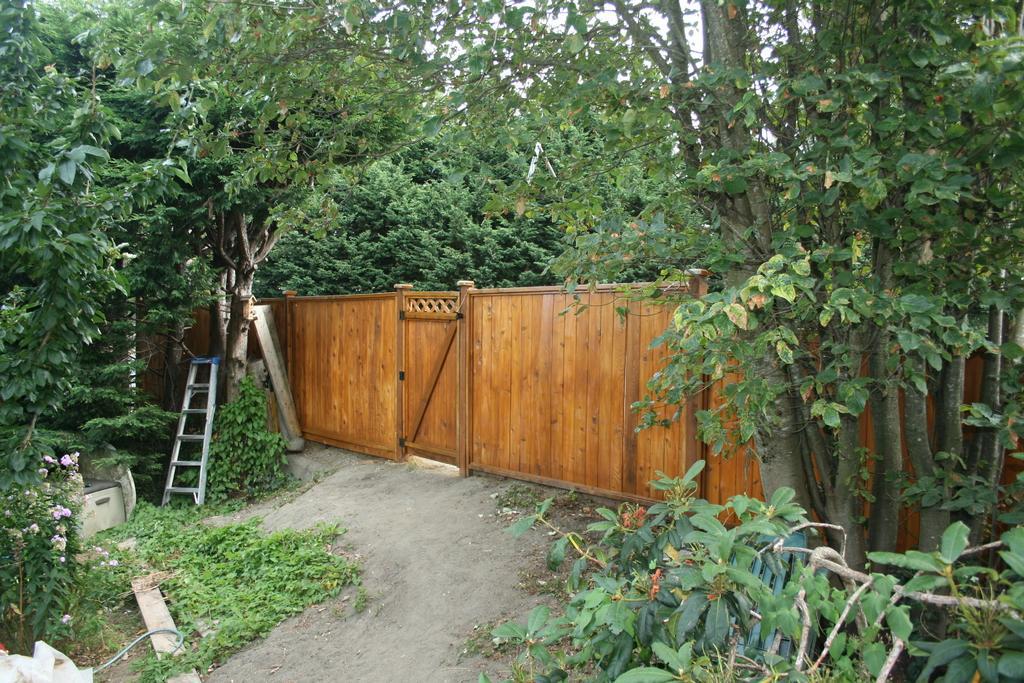Could you give a brief overview of what you see in this image? This image is taken outdoors. At the bottom of the image there is ground. In the middle of the image there is a gate and there is a wooden fence. There is a ladder. In this image there are many trees and plants with green leaves, stems and branches. 